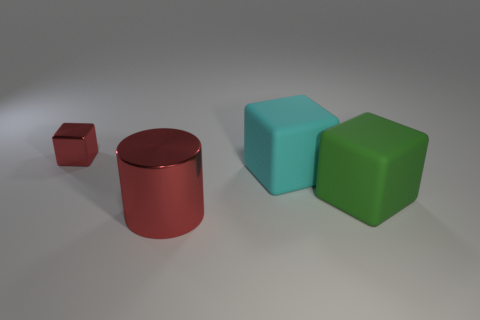Add 1 small metallic objects. How many objects exist? 5 Subtract all cylinders. How many objects are left? 3 Subtract 0 blue cylinders. How many objects are left? 4 Subtract all red cylinders. Subtract all rubber things. How many objects are left? 1 Add 2 large cylinders. How many large cylinders are left? 3 Add 4 yellow matte objects. How many yellow matte objects exist? 4 